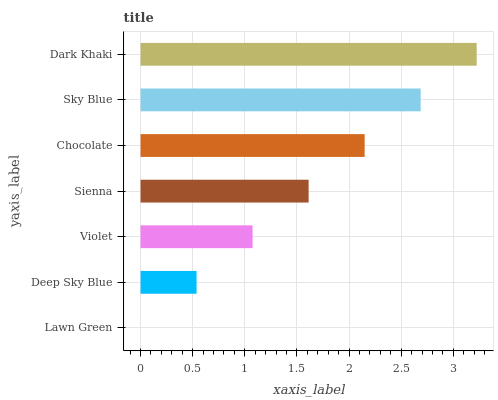Is Lawn Green the minimum?
Answer yes or no. Yes. Is Dark Khaki the maximum?
Answer yes or no. Yes. Is Deep Sky Blue the minimum?
Answer yes or no. No. Is Deep Sky Blue the maximum?
Answer yes or no. No. Is Deep Sky Blue greater than Lawn Green?
Answer yes or no. Yes. Is Lawn Green less than Deep Sky Blue?
Answer yes or no. Yes. Is Lawn Green greater than Deep Sky Blue?
Answer yes or no. No. Is Deep Sky Blue less than Lawn Green?
Answer yes or no. No. Is Sienna the high median?
Answer yes or no. Yes. Is Sienna the low median?
Answer yes or no. Yes. Is Violet the high median?
Answer yes or no. No. Is Violet the low median?
Answer yes or no. No. 